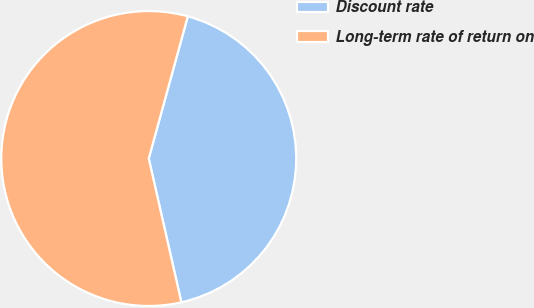Convert chart to OTSL. <chart><loc_0><loc_0><loc_500><loc_500><pie_chart><fcel>Discount rate<fcel>Long-term rate of return on<nl><fcel>42.18%<fcel>57.82%<nl></chart> 